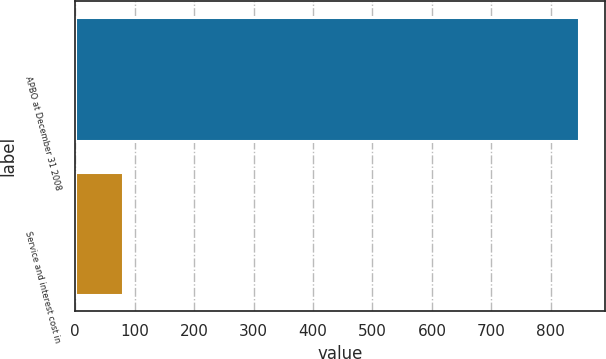Convert chart to OTSL. <chart><loc_0><loc_0><loc_500><loc_500><bar_chart><fcel>APBO at December 31 2008<fcel>Service and interest cost in<nl><fcel>848<fcel>80<nl></chart> 